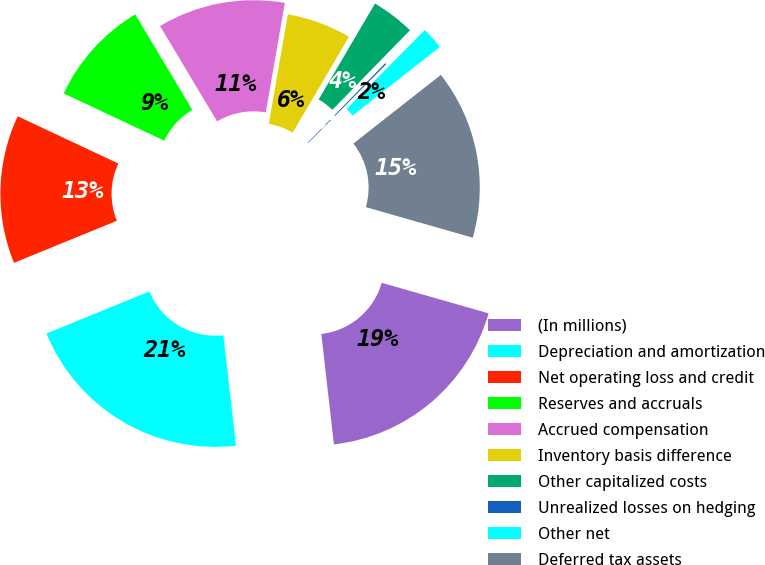<chart> <loc_0><loc_0><loc_500><loc_500><pie_chart><fcel>(In millions)<fcel>Depreciation and amortization<fcel>Net operating loss and credit<fcel>Reserves and accruals<fcel>Accrued compensation<fcel>Inventory basis difference<fcel>Other capitalized costs<fcel>Unrealized losses on hedging<fcel>Other net<fcel>Deferred tax assets<nl><fcel>18.76%<fcel>20.63%<fcel>13.17%<fcel>9.44%<fcel>11.31%<fcel>5.71%<fcel>3.85%<fcel>0.12%<fcel>1.98%<fcel>15.03%<nl></chart> 